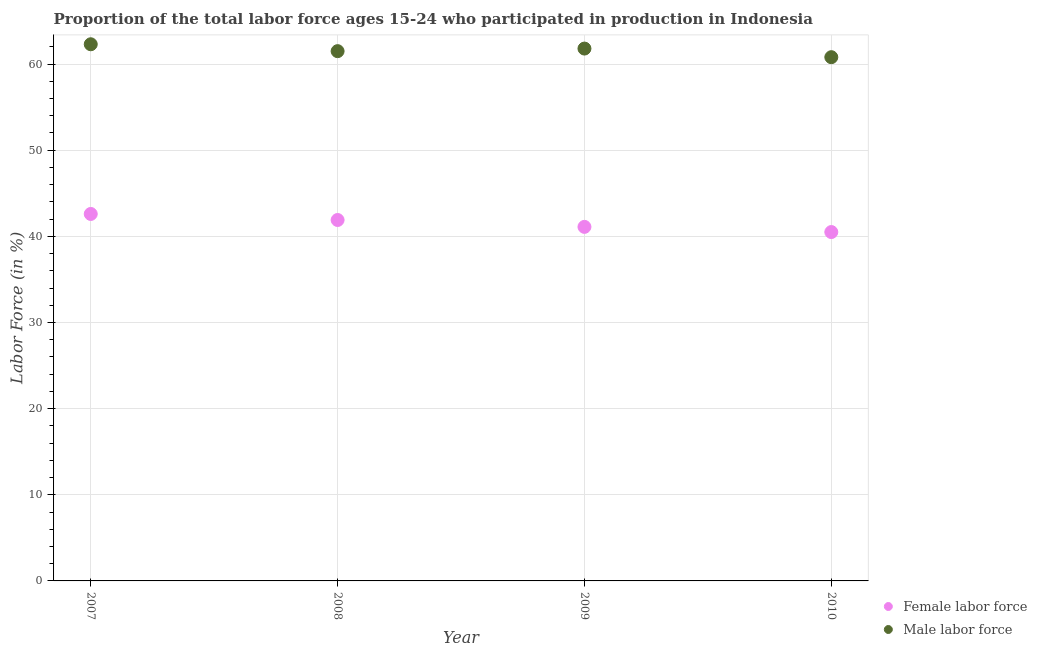How many different coloured dotlines are there?
Keep it short and to the point. 2. Is the number of dotlines equal to the number of legend labels?
Offer a terse response. Yes. What is the percentage of female labor force in 2010?
Keep it short and to the point. 40.5. Across all years, what is the maximum percentage of male labour force?
Keep it short and to the point. 62.3. Across all years, what is the minimum percentage of male labour force?
Offer a very short reply. 60.8. What is the total percentage of female labor force in the graph?
Ensure brevity in your answer.  166.1. What is the difference between the percentage of female labor force in 2008 and that in 2010?
Provide a short and direct response. 1.4. What is the difference between the percentage of male labour force in 2007 and the percentage of female labor force in 2008?
Keep it short and to the point. 20.4. What is the average percentage of female labor force per year?
Your answer should be compact. 41.52. In the year 2007, what is the difference between the percentage of male labour force and percentage of female labor force?
Your response must be concise. 19.7. In how many years, is the percentage of female labor force greater than 42 %?
Provide a succinct answer. 1. What is the ratio of the percentage of female labor force in 2009 to that in 2010?
Make the answer very short. 1.01. What is the difference between the highest and the second highest percentage of female labor force?
Provide a succinct answer. 0.7. In how many years, is the percentage of female labor force greater than the average percentage of female labor force taken over all years?
Offer a terse response. 2. Does the percentage of male labour force monotonically increase over the years?
Make the answer very short. No. Is the percentage of male labour force strictly less than the percentage of female labor force over the years?
Make the answer very short. No. What is the difference between two consecutive major ticks on the Y-axis?
Give a very brief answer. 10. Are the values on the major ticks of Y-axis written in scientific E-notation?
Offer a very short reply. No. Does the graph contain grids?
Offer a terse response. Yes. How many legend labels are there?
Keep it short and to the point. 2. How are the legend labels stacked?
Give a very brief answer. Vertical. What is the title of the graph?
Offer a very short reply. Proportion of the total labor force ages 15-24 who participated in production in Indonesia. What is the label or title of the X-axis?
Ensure brevity in your answer.  Year. What is the Labor Force (in %) of Female labor force in 2007?
Make the answer very short. 42.6. What is the Labor Force (in %) of Male labor force in 2007?
Your answer should be very brief. 62.3. What is the Labor Force (in %) of Female labor force in 2008?
Provide a succinct answer. 41.9. What is the Labor Force (in %) in Male labor force in 2008?
Your answer should be compact. 61.5. What is the Labor Force (in %) in Female labor force in 2009?
Ensure brevity in your answer.  41.1. What is the Labor Force (in %) in Male labor force in 2009?
Give a very brief answer. 61.8. What is the Labor Force (in %) in Female labor force in 2010?
Offer a very short reply. 40.5. What is the Labor Force (in %) of Male labor force in 2010?
Your answer should be compact. 60.8. Across all years, what is the maximum Labor Force (in %) in Female labor force?
Make the answer very short. 42.6. Across all years, what is the maximum Labor Force (in %) of Male labor force?
Your answer should be very brief. 62.3. Across all years, what is the minimum Labor Force (in %) in Female labor force?
Provide a succinct answer. 40.5. Across all years, what is the minimum Labor Force (in %) in Male labor force?
Give a very brief answer. 60.8. What is the total Labor Force (in %) in Female labor force in the graph?
Your response must be concise. 166.1. What is the total Labor Force (in %) of Male labor force in the graph?
Offer a terse response. 246.4. What is the difference between the Labor Force (in %) of Male labor force in 2007 and that in 2008?
Provide a short and direct response. 0.8. What is the difference between the Labor Force (in %) in Female labor force in 2007 and that in 2010?
Give a very brief answer. 2.1. What is the difference between the Labor Force (in %) of Male labor force in 2007 and that in 2010?
Keep it short and to the point. 1.5. What is the difference between the Labor Force (in %) in Male labor force in 2008 and that in 2009?
Keep it short and to the point. -0.3. What is the difference between the Labor Force (in %) of Female labor force in 2008 and that in 2010?
Give a very brief answer. 1.4. What is the difference between the Labor Force (in %) in Female labor force in 2007 and the Labor Force (in %) in Male labor force in 2008?
Provide a succinct answer. -18.9. What is the difference between the Labor Force (in %) of Female labor force in 2007 and the Labor Force (in %) of Male labor force in 2009?
Keep it short and to the point. -19.2. What is the difference between the Labor Force (in %) of Female labor force in 2007 and the Labor Force (in %) of Male labor force in 2010?
Offer a terse response. -18.2. What is the difference between the Labor Force (in %) of Female labor force in 2008 and the Labor Force (in %) of Male labor force in 2009?
Offer a very short reply. -19.9. What is the difference between the Labor Force (in %) of Female labor force in 2008 and the Labor Force (in %) of Male labor force in 2010?
Offer a terse response. -18.9. What is the difference between the Labor Force (in %) of Female labor force in 2009 and the Labor Force (in %) of Male labor force in 2010?
Make the answer very short. -19.7. What is the average Labor Force (in %) in Female labor force per year?
Offer a very short reply. 41.52. What is the average Labor Force (in %) in Male labor force per year?
Offer a very short reply. 61.6. In the year 2007, what is the difference between the Labor Force (in %) of Female labor force and Labor Force (in %) of Male labor force?
Your response must be concise. -19.7. In the year 2008, what is the difference between the Labor Force (in %) in Female labor force and Labor Force (in %) in Male labor force?
Offer a terse response. -19.6. In the year 2009, what is the difference between the Labor Force (in %) of Female labor force and Labor Force (in %) of Male labor force?
Ensure brevity in your answer.  -20.7. In the year 2010, what is the difference between the Labor Force (in %) in Female labor force and Labor Force (in %) in Male labor force?
Offer a terse response. -20.3. What is the ratio of the Labor Force (in %) of Female labor force in 2007 to that in 2008?
Provide a succinct answer. 1.02. What is the ratio of the Labor Force (in %) in Female labor force in 2007 to that in 2009?
Provide a short and direct response. 1.04. What is the ratio of the Labor Force (in %) in Female labor force in 2007 to that in 2010?
Your answer should be compact. 1.05. What is the ratio of the Labor Force (in %) in Male labor force in 2007 to that in 2010?
Give a very brief answer. 1.02. What is the ratio of the Labor Force (in %) in Female labor force in 2008 to that in 2009?
Offer a terse response. 1.02. What is the ratio of the Labor Force (in %) in Female labor force in 2008 to that in 2010?
Make the answer very short. 1.03. What is the ratio of the Labor Force (in %) in Male labor force in 2008 to that in 2010?
Make the answer very short. 1.01. What is the ratio of the Labor Force (in %) in Female labor force in 2009 to that in 2010?
Keep it short and to the point. 1.01. What is the ratio of the Labor Force (in %) in Male labor force in 2009 to that in 2010?
Keep it short and to the point. 1.02. What is the difference between the highest and the second highest Labor Force (in %) of Female labor force?
Provide a short and direct response. 0.7. What is the difference between the highest and the lowest Labor Force (in %) in Female labor force?
Your answer should be compact. 2.1. 